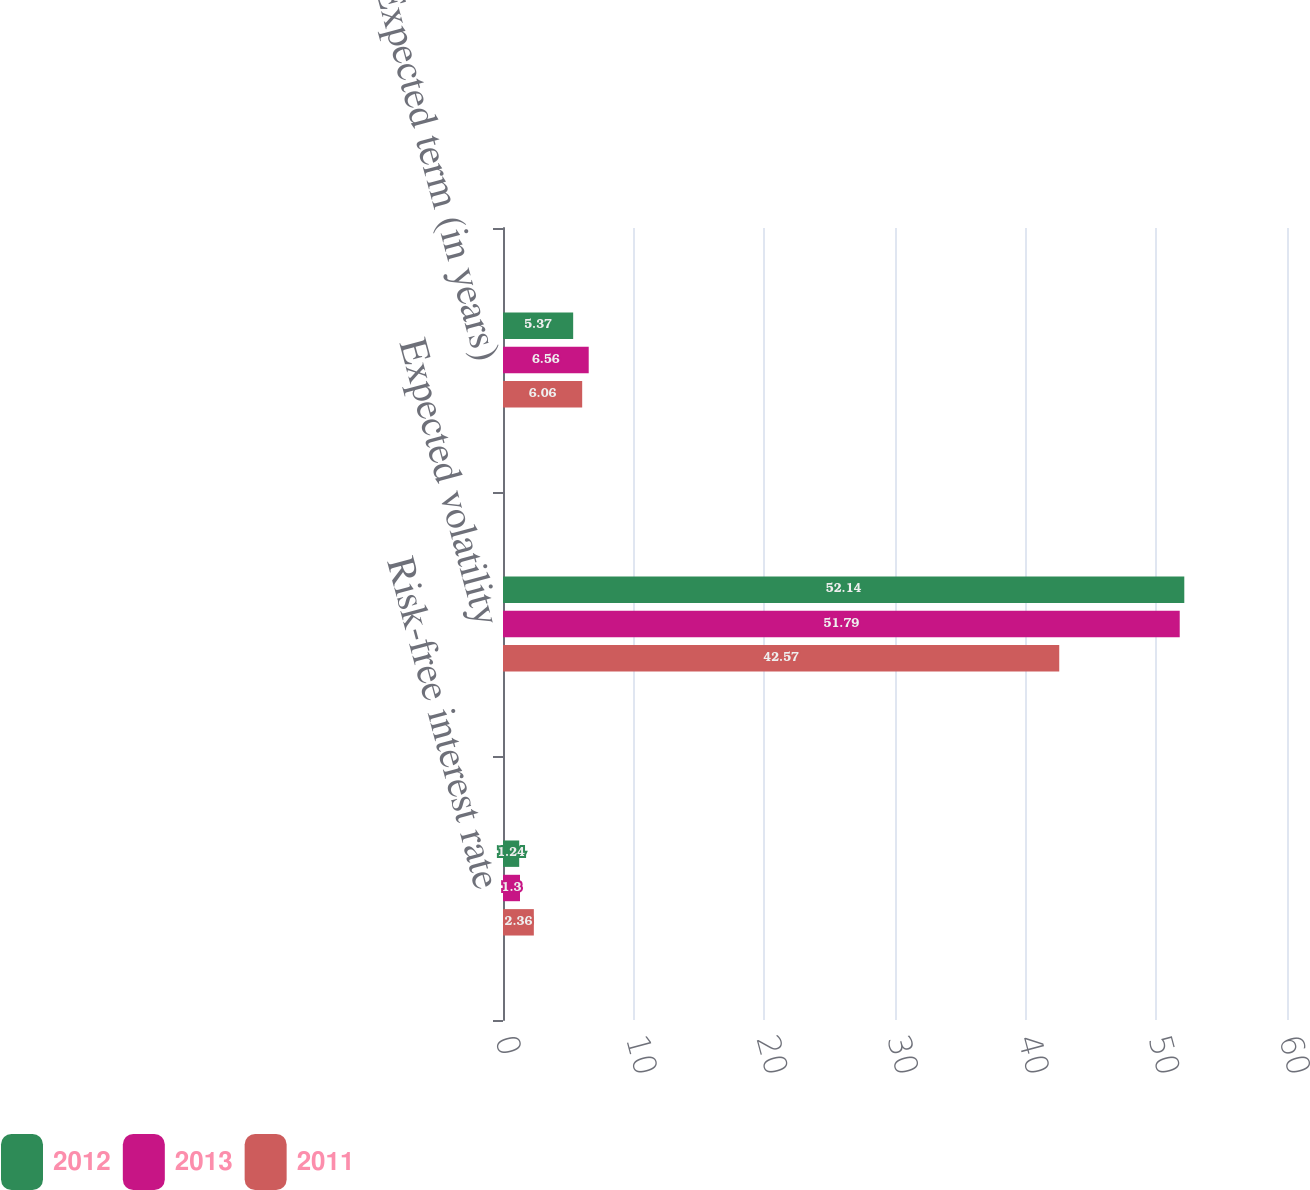Convert chart. <chart><loc_0><loc_0><loc_500><loc_500><stacked_bar_chart><ecel><fcel>Risk-free interest rate<fcel>Expected volatility<fcel>Expected term (in years)<nl><fcel>2012<fcel>1.24<fcel>52.14<fcel>5.37<nl><fcel>2013<fcel>1.3<fcel>51.79<fcel>6.56<nl><fcel>2011<fcel>2.36<fcel>42.57<fcel>6.06<nl></chart> 